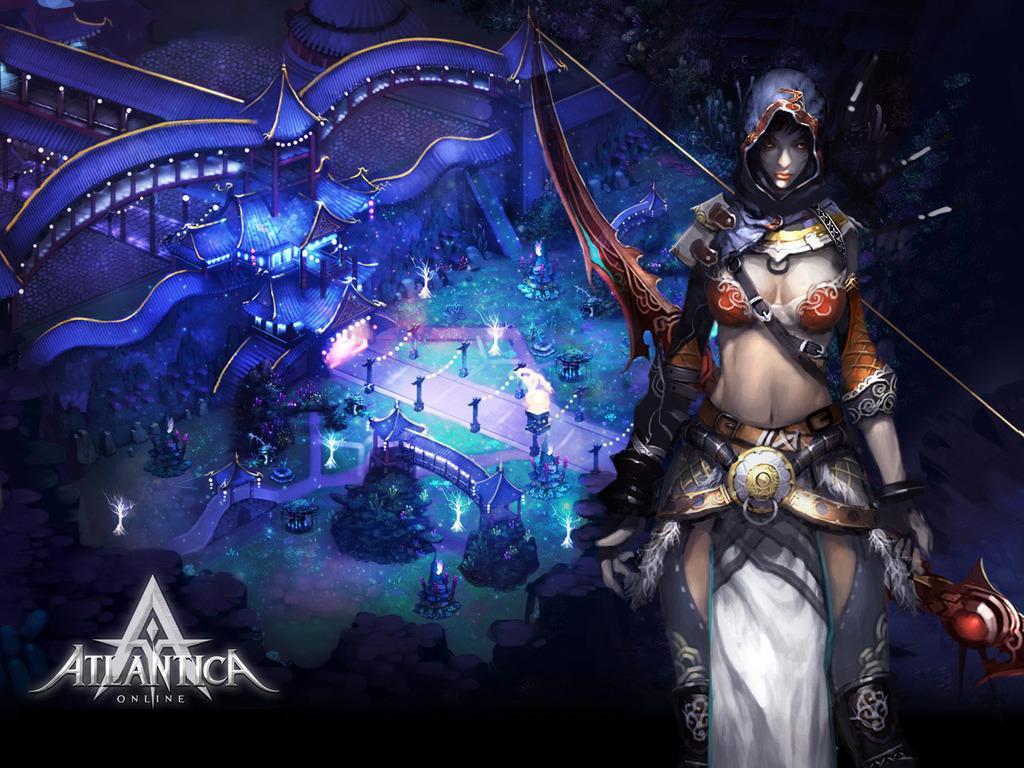Can you describe this image briefly? The image is an animation picture in which we can see there is a woman standing and holding a weapon in her hand. Behind there is a building and there are lightings. On the image its written "ATLANTICA Online". 